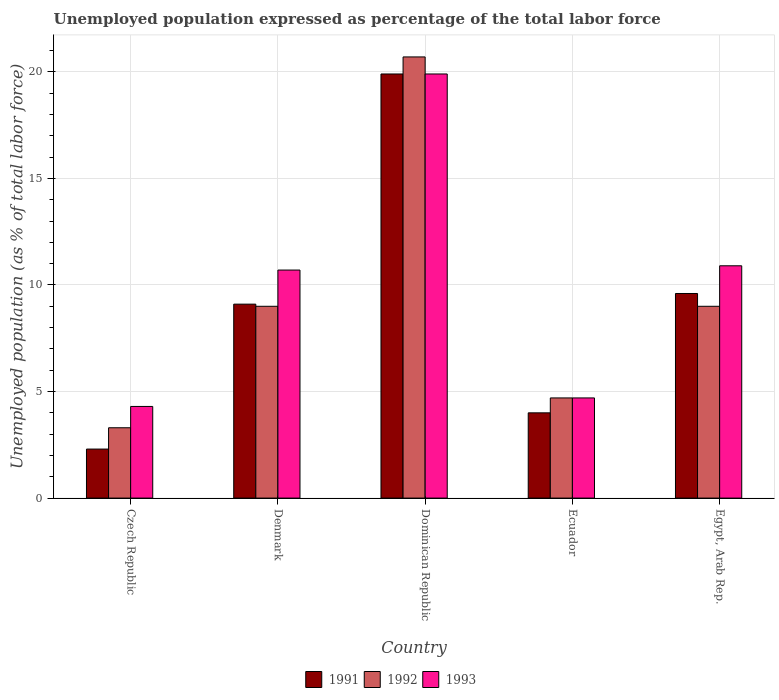How many different coloured bars are there?
Keep it short and to the point. 3. How many groups of bars are there?
Make the answer very short. 5. Are the number of bars per tick equal to the number of legend labels?
Provide a succinct answer. Yes. How many bars are there on the 2nd tick from the left?
Provide a short and direct response. 3. What is the label of the 4th group of bars from the left?
Provide a short and direct response. Ecuador. In how many cases, is the number of bars for a given country not equal to the number of legend labels?
Your response must be concise. 0. What is the unemployment in in 1992 in Dominican Republic?
Keep it short and to the point. 20.7. Across all countries, what is the maximum unemployment in in 1991?
Give a very brief answer. 19.9. Across all countries, what is the minimum unemployment in in 1993?
Keep it short and to the point. 4.3. In which country was the unemployment in in 1992 maximum?
Ensure brevity in your answer.  Dominican Republic. In which country was the unemployment in in 1992 minimum?
Your response must be concise. Czech Republic. What is the total unemployment in in 1991 in the graph?
Your answer should be very brief. 44.9. What is the difference between the unemployment in in 1993 in Czech Republic and that in Denmark?
Provide a short and direct response. -6.4. What is the difference between the unemployment in in 1992 in Egypt, Arab Rep. and the unemployment in in 1993 in Denmark?
Provide a short and direct response. -1.7. What is the average unemployment in in 1991 per country?
Provide a succinct answer. 8.98. What is the difference between the unemployment in of/in 1992 and unemployment in of/in 1991 in Dominican Republic?
Your answer should be compact. 0.8. What is the ratio of the unemployment in in 1993 in Denmark to that in Ecuador?
Make the answer very short. 2.28. Is the unemployment in in 1991 in Czech Republic less than that in Ecuador?
Your response must be concise. Yes. Is the difference between the unemployment in in 1992 in Dominican Republic and Egypt, Arab Rep. greater than the difference between the unemployment in in 1991 in Dominican Republic and Egypt, Arab Rep.?
Ensure brevity in your answer.  Yes. What is the difference between the highest and the second highest unemployment in in 1993?
Provide a succinct answer. -9. What is the difference between the highest and the lowest unemployment in in 1992?
Your response must be concise. 17.4. Is the sum of the unemployment in in 1992 in Czech Republic and Ecuador greater than the maximum unemployment in in 1993 across all countries?
Provide a succinct answer. No. What does the 1st bar from the right in Egypt, Arab Rep. represents?
Provide a succinct answer. 1993. Is it the case that in every country, the sum of the unemployment in in 1992 and unemployment in in 1991 is greater than the unemployment in in 1993?
Keep it short and to the point. Yes. Are all the bars in the graph horizontal?
Make the answer very short. No. How many countries are there in the graph?
Keep it short and to the point. 5. Does the graph contain any zero values?
Your answer should be very brief. No. Does the graph contain grids?
Your response must be concise. Yes. Where does the legend appear in the graph?
Provide a short and direct response. Bottom center. What is the title of the graph?
Provide a short and direct response. Unemployed population expressed as percentage of the total labor force. What is the label or title of the Y-axis?
Your response must be concise. Unemployed population (as % of total labor force). What is the Unemployed population (as % of total labor force) in 1991 in Czech Republic?
Provide a short and direct response. 2.3. What is the Unemployed population (as % of total labor force) of 1992 in Czech Republic?
Offer a terse response. 3.3. What is the Unemployed population (as % of total labor force) of 1993 in Czech Republic?
Make the answer very short. 4.3. What is the Unemployed population (as % of total labor force) in 1991 in Denmark?
Make the answer very short. 9.1. What is the Unemployed population (as % of total labor force) of 1993 in Denmark?
Make the answer very short. 10.7. What is the Unemployed population (as % of total labor force) of 1991 in Dominican Republic?
Provide a succinct answer. 19.9. What is the Unemployed population (as % of total labor force) in 1992 in Dominican Republic?
Provide a succinct answer. 20.7. What is the Unemployed population (as % of total labor force) in 1993 in Dominican Republic?
Keep it short and to the point. 19.9. What is the Unemployed population (as % of total labor force) in 1992 in Ecuador?
Keep it short and to the point. 4.7. What is the Unemployed population (as % of total labor force) in 1993 in Ecuador?
Your response must be concise. 4.7. What is the Unemployed population (as % of total labor force) of 1991 in Egypt, Arab Rep.?
Give a very brief answer. 9.6. What is the Unemployed population (as % of total labor force) in 1993 in Egypt, Arab Rep.?
Provide a succinct answer. 10.9. Across all countries, what is the maximum Unemployed population (as % of total labor force) in 1991?
Provide a succinct answer. 19.9. Across all countries, what is the maximum Unemployed population (as % of total labor force) in 1992?
Your answer should be compact. 20.7. Across all countries, what is the maximum Unemployed population (as % of total labor force) in 1993?
Make the answer very short. 19.9. Across all countries, what is the minimum Unemployed population (as % of total labor force) of 1991?
Provide a succinct answer. 2.3. Across all countries, what is the minimum Unemployed population (as % of total labor force) in 1992?
Your answer should be compact. 3.3. Across all countries, what is the minimum Unemployed population (as % of total labor force) in 1993?
Provide a succinct answer. 4.3. What is the total Unemployed population (as % of total labor force) in 1991 in the graph?
Give a very brief answer. 44.9. What is the total Unemployed population (as % of total labor force) of 1992 in the graph?
Give a very brief answer. 46.7. What is the total Unemployed population (as % of total labor force) in 1993 in the graph?
Your answer should be compact. 50.5. What is the difference between the Unemployed population (as % of total labor force) of 1991 in Czech Republic and that in Denmark?
Your answer should be compact. -6.8. What is the difference between the Unemployed population (as % of total labor force) in 1992 in Czech Republic and that in Denmark?
Provide a succinct answer. -5.7. What is the difference between the Unemployed population (as % of total labor force) in 1991 in Czech Republic and that in Dominican Republic?
Your answer should be compact. -17.6. What is the difference between the Unemployed population (as % of total labor force) of 1992 in Czech Republic and that in Dominican Republic?
Your answer should be very brief. -17.4. What is the difference between the Unemployed population (as % of total labor force) in 1993 in Czech Republic and that in Dominican Republic?
Offer a very short reply. -15.6. What is the difference between the Unemployed population (as % of total labor force) of 1991 in Czech Republic and that in Ecuador?
Offer a very short reply. -1.7. What is the difference between the Unemployed population (as % of total labor force) of 1992 in Czech Republic and that in Ecuador?
Your answer should be compact. -1.4. What is the difference between the Unemployed population (as % of total labor force) in 1993 in Czech Republic and that in Ecuador?
Provide a succinct answer. -0.4. What is the difference between the Unemployed population (as % of total labor force) of 1991 in Czech Republic and that in Egypt, Arab Rep.?
Your response must be concise. -7.3. What is the difference between the Unemployed population (as % of total labor force) of 1993 in Czech Republic and that in Egypt, Arab Rep.?
Make the answer very short. -6.6. What is the difference between the Unemployed population (as % of total labor force) of 1991 in Denmark and that in Dominican Republic?
Make the answer very short. -10.8. What is the difference between the Unemployed population (as % of total labor force) in 1992 in Denmark and that in Dominican Republic?
Your answer should be very brief. -11.7. What is the difference between the Unemployed population (as % of total labor force) of 1993 in Denmark and that in Egypt, Arab Rep.?
Offer a terse response. -0.2. What is the difference between the Unemployed population (as % of total labor force) of 1992 in Dominican Republic and that in Egypt, Arab Rep.?
Keep it short and to the point. 11.7. What is the difference between the Unemployed population (as % of total labor force) of 1993 in Dominican Republic and that in Egypt, Arab Rep.?
Your answer should be very brief. 9. What is the difference between the Unemployed population (as % of total labor force) in 1992 in Ecuador and that in Egypt, Arab Rep.?
Provide a short and direct response. -4.3. What is the difference between the Unemployed population (as % of total labor force) of 1992 in Czech Republic and the Unemployed population (as % of total labor force) of 1993 in Denmark?
Your answer should be compact. -7.4. What is the difference between the Unemployed population (as % of total labor force) in 1991 in Czech Republic and the Unemployed population (as % of total labor force) in 1992 in Dominican Republic?
Ensure brevity in your answer.  -18.4. What is the difference between the Unemployed population (as % of total labor force) in 1991 in Czech Republic and the Unemployed population (as % of total labor force) in 1993 in Dominican Republic?
Keep it short and to the point. -17.6. What is the difference between the Unemployed population (as % of total labor force) of 1992 in Czech Republic and the Unemployed population (as % of total labor force) of 1993 in Dominican Republic?
Give a very brief answer. -16.6. What is the difference between the Unemployed population (as % of total labor force) in 1991 in Czech Republic and the Unemployed population (as % of total labor force) in 1992 in Ecuador?
Your response must be concise. -2.4. What is the difference between the Unemployed population (as % of total labor force) of 1991 in Czech Republic and the Unemployed population (as % of total labor force) of 1993 in Ecuador?
Give a very brief answer. -2.4. What is the difference between the Unemployed population (as % of total labor force) in 1992 in Czech Republic and the Unemployed population (as % of total labor force) in 1993 in Ecuador?
Provide a short and direct response. -1.4. What is the difference between the Unemployed population (as % of total labor force) of 1991 in Czech Republic and the Unemployed population (as % of total labor force) of 1993 in Egypt, Arab Rep.?
Ensure brevity in your answer.  -8.6. What is the difference between the Unemployed population (as % of total labor force) in 1992 in Czech Republic and the Unemployed population (as % of total labor force) in 1993 in Egypt, Arab Rep.?
Ensure brevity in your answer.  -7.6. What is the difference between the Unemployed population (as % of total labor force) of 1991 in Denmark and the Unemployed population (as % of total labor force) of 1992 in Dominican Republic?
Offer a very short reply. -11.6. What is the difference between the Unemployed population (as % of total labor force) in 1991 in Denmark and the Unemployed population (as % of total labor force) in 1993 in Dominican Republic?
Your response must be concise. -10.8. What is the difference between the Unemployed population (as % of total labor force) in 1991 in Denmark and the Unemployed population (as % of total labor force) in 1993 in Egypt, Arab Rep.?
Make the answer very short. -1.8. What is the difference between the Unemployed population (as % of total labor force) of 1992 in Denmark and the Unemployed population (as % of total labor force) of 1993 in Egypt, Arab Rep.?
Ensure brevity in your answer.  -1.9. What is the difference between the Unemployed population (as % of total labor force) of 1991 in Dominican Republic and the Unemployed population (as % of total labor force) of 1992 in Ecuador?
Your response must be concise. 15.2. What is the difference between the Unemployed population (as % of total labor force) of 1991 in Dominican Republic and the Unemployed population (as % of total labor force) of 1993 in Ecuador?
Give a very brief answer. 15.2. What is the difference between the Unemployed population (as % of total labor force) in 1992 in Dominican Republic and the Unemployed population (as % of total labor force) in 1993 in Ecuador?
Make the answer very short. 16. What is the difference between the Unemployed population (as % of total labor force) in 1991 in Dominican Republic and the Unemployed population (as % of total labor force) in 1993 in Egypt, Arab Rep.?
Your answer should be very brief. 9. What is the difference between the Unemployed population (as % of total labor force) in 1992 in Ecuador and the Unemployed population (as % of total labor force) in 1993 in Egypt, Arab Rep.?
Keep it short and to the point. -6.2. What is the average Unemployed population (as % of total labor force) in 1991 per country?
Keep it short and to the point. 8.98. What is the average Unemployed population (as % of total labor force) in 1992 per country?
Provide a short and direct response. 9.34. What is the difference between the Unemployed population (as % of total labor force) in 1991 and Unemployed population (as % of total labor force) in 1992 in Czech Republic?
Give a very brief answer. -1. What is the difference between the Unemployed population (as % of total labor force) of 1991 and Unemployed population (as % of total labor force) of 1993 in Czech Republic?
Make the answer very short. -2. What is the difference between the Unemployed population (as % of total labor force) in 1992 and Unemployed population (as % of total labor force) in 1993 in Czech Republic?
Your response must be concise. -1. What is the difference between the Unemployed population (as % of total labor force) in 1991 and Unemployed population (as % of total labor force) in 1992 in Denmark?
Ensure brevity in your answer.  0.1. What is the difference between the Unemployed population (as % of total labor force) in 1991 and Unemployed population (as % of total labor force) in 1993 in Denmark?
Give a very brief answer. -1.6. What is the difference between the Unemployed population (as % of total labor force) in 1992 and Unemployed population (as % of total labor force) in 1993 in Denmark?
Your answer should be very brief. -1.7. What is the difference between the Unemployed population (as % of total labor force) of 1991 and Unemployed population (as % of total labor force) of 1992 in Dominican Republic?
Your answer should be very brief. -0.8. What is the difference between the Unemployed population (as % of total labor force) in 1991 and Unemployed population (as % of total labor force) in 1993 in Ecuador?
Offer a terse response. -0.7. What is the difference between the Unemployed population (as % of total labor force) of 1991 and Unemployed population (as % of total labor force) of 1992 in Egypt, Arab Rep.?
Your response must be concise. 0.6. What is the ratio of the Unemployed population (as % of total labor force) of 1991 in Czech Republic to that in Denmark?
Provide a short and direct response. 0.25. What is the ratio of the Unemployed population (as % of total labor force) in 1992 in Czech Republic to that in Denmark?
Provide a short and direct response. 0.37. What is the ratio of the Unemployed population (as % of total labor force) in 1993 in Czech Republic to that in Denmark?
Your response must be concise. 0.4. What is the ratio of the Unemployed population (as % of total labor force) of 1991 in Czech Republic to that in Dominican Republic?
Make the answer very short. 0.12. What is the ratio of the Unemployed population (as % of total labor force) of 1992 in Czech Republic to that in Dominican Republic?
Provide a short and direct response. 0.16. What is the ratio of the Unemployed population (as % of total labor force) of 1993 in Czech Republic to that in Dominican Republic?
Keep it short and to the point. 0.22. What is the ratio of the Unemployed population (as % of total labor force) of 1991 in Czech Republic to that in Ecuador?
Provide a succinct answer. 0.57. What is the ratio of the Unemployed population (as % of total labor force) of 1992 in Czech Republic to that in Ecuador?
Ensure brevity in your answer.  0.7. What is the ratio of the Unemployed population (as % of total labor force) in 1993 in Czech Republic to that in Ecuador?
Offer a very short reply. 0.91. What is the ratio of the Unemployed population (as % of total labor force) in 1991 in Czech Republic to that in Egypt, Arab Rep.?
Provide a short and direct response. 0.24. What is the ratio of the Unemployed population (as % of total labor force) in 1992 in Czech Republic to that in Egypt, Arab Rep.?
Keep it short and to the point. 0.37. What is the ratio of the Unemployed population (as % of total labor force) in 1993 in Czech Republic to that in Egypt, Arab Rep.?
Your response must be concise. 0.39. What is the ratio of the Unemployed population (as % of total labor force) in 1991 in Denmark to that in Dominican Republic?
Offer a terse response. 0.46. What is the ratio of the Unemployed population (as % of total labor force) of 1992 in Denmark to that in Dominican Republic?
Your answer should be very brief. 0.43. What is the ratio of the Unemployed population (as % of total labor force) in 1993 in Denmark to that in Dominican Republic?
Keep it short and to the point. 0.54. What is the ratio of the Unemployed population (as % of total labor force) in 1991 in Denmark to that in Ecuador?
Your response must be concise. 2.27. What is the ratio of the Unemployed population (as % of total labor force) of 1992 in Denmark to that in Ecuador?
Offer a terse response. 1.91. What is the ratio of the Unemployed population (as % of total labor force) in 1993 in Denmark to that in Ecuador?
Give a very brief answer. 2.28. What is the ratio of the Unemployed population (as % of total labor force) of 1991 in Denmark to that in Egypt, Arab Rep.?
Provide a short and direct response. 0.95. What is the ratio of the Unemployed population (as % of total labor force) in 1993 in Denmark to that in Egypt, Arab Rep.?
Your response must be concise. 0.98. What is the ratio of the Unemployed population (as % of total labor force) of 1991 in Dominican Republic to that in Ecuador?
Your response must be concise. 4.97. What is the ratio of the Unemployed population (as % of total labor force) of 1992 in Dominican Republic to that in Ecuador?
Offer a very short reply. 4.4. What is the ratio of the Unemployed population (as % of total labor force) in 1993 in Dominican Republic to that in Ecuador?
Provide a succinct answer. 4.23. What is the ratio of the Unemployed population (as % of total labor force) of 1991 in Dominican Republic to that in Egypt, Arab Rep.?
Your answer should be very brief. 2.07. What is the ratio of the Unemployed population (as % of total labor force) in 1992 in Dominican Republic to that in Egypt, Arab Rep.?
Offer a terse response. 2.3. What is the ratio of the Unemployed population (as % of total labor force) in 1993 in Dominican Republic to that in Egypt, Arab Rep.?
Offer a very short reply. 1.83. What is the ratio of the Unemployed population (as % of total labor force) in 1991 in Ecuador to that in Egypt, Arab Rep.?
Provide a succinct answer. 0.42. What is the ratio of the Unemployed population (as % of total labor force) in 1992 in Ecuador to that in Egypt, Arab Rep.?
Provide a short and direct response. 0.52. What is the ratio of the Unemployed population (as % of total labor force) in 1993 in Ecuador to that in Egypt, Arab Rep.?
Give a very brief answer. 0.43. 